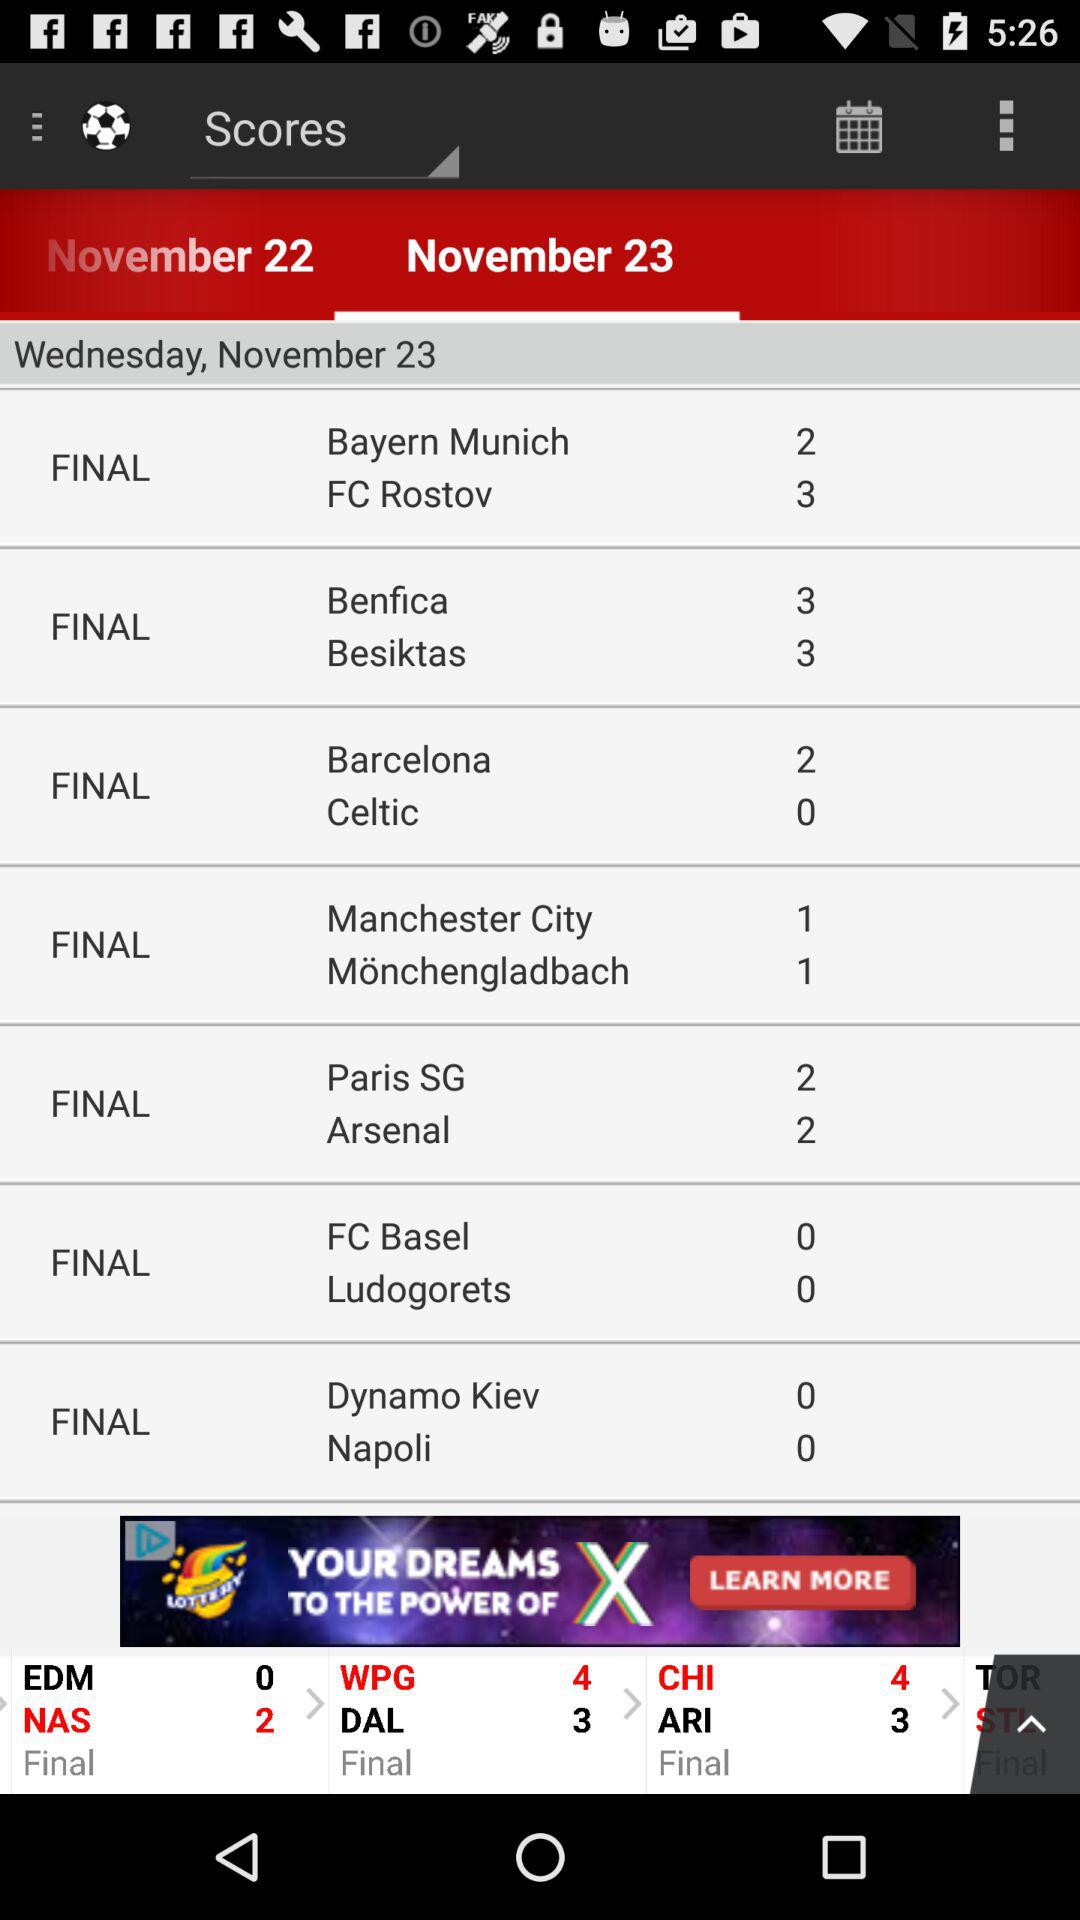On what day is the match between "Barcelona" and "Celtic"? The match is on Wednesday, November 23. 